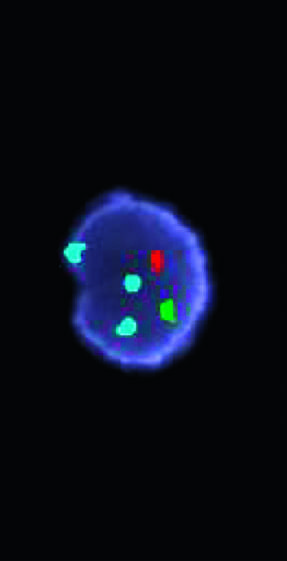how many copies does the green probe hybridize to the x chromosome centromere?
Answer the question using a single word or phrase. One 